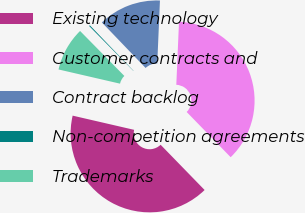<chart> <loc_0><loc_0><loc_500><loc_500><pie_chart><fcel>Existing technology<fcel>Customer contracts and<fcel>Contract backlog<fcel>Non-competition agreements<fcel>Trademarks<nl><fcel>40.89%<fcel>37.04%<fcel>12.86%<fcel>0.2%<fcel>9.01%<nl></chart> 